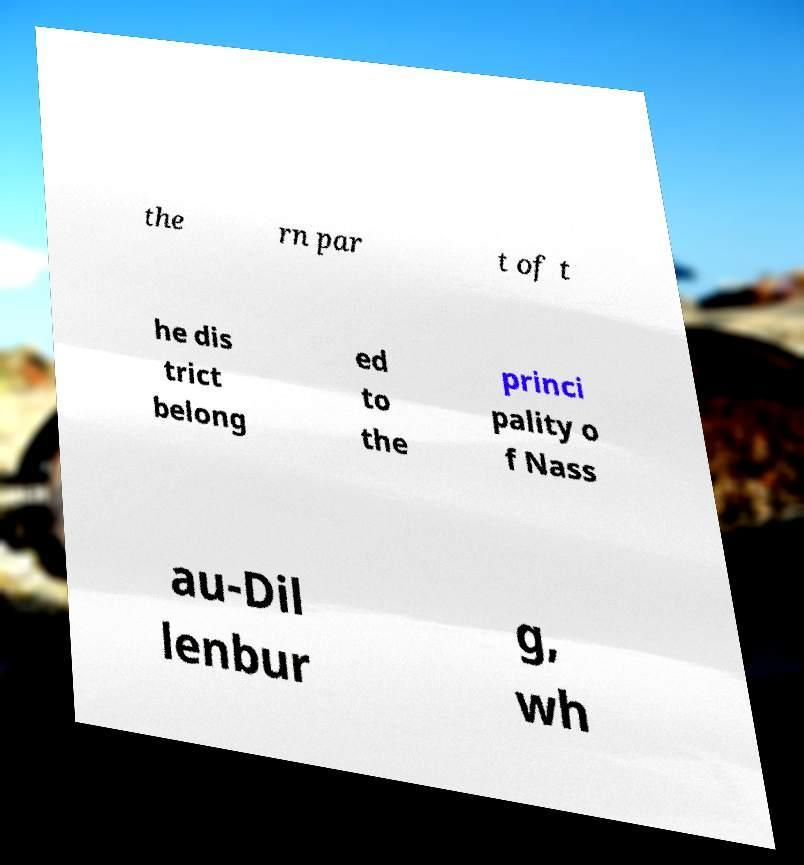Can you read and provide the text displayed in the image?This photo seems to have some interesting text. Can you extract and type it out for me? the rn par t of t he dis trict belong ed to the princi pality o f Nass au-Dil lenbur g, wh 